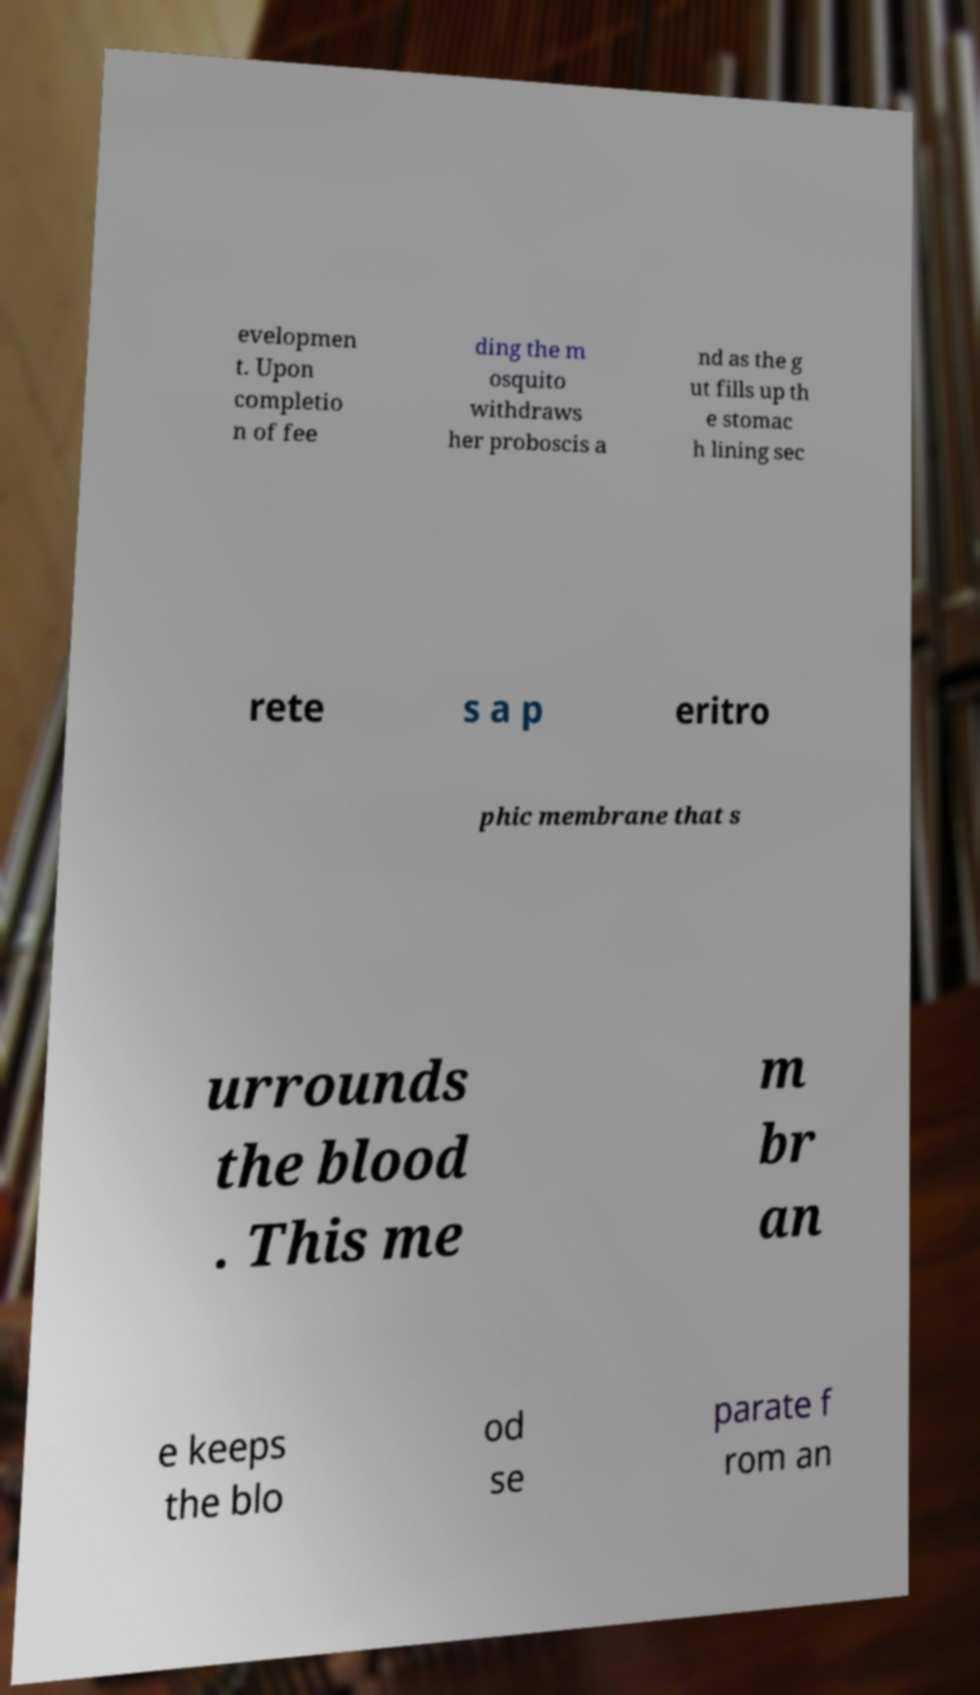There's text embedded in this image that I need extracted. Can you transcribe it verbatim? evelopmen t. Upon completio n of fee ding the m osquito withdraws her proboscis a nd as the g ut fills up th e stomac h lining sec rete s a p eritro phic membrane that s urrounds the blood . This me m br an e keeps the blo od se parate f rom an 